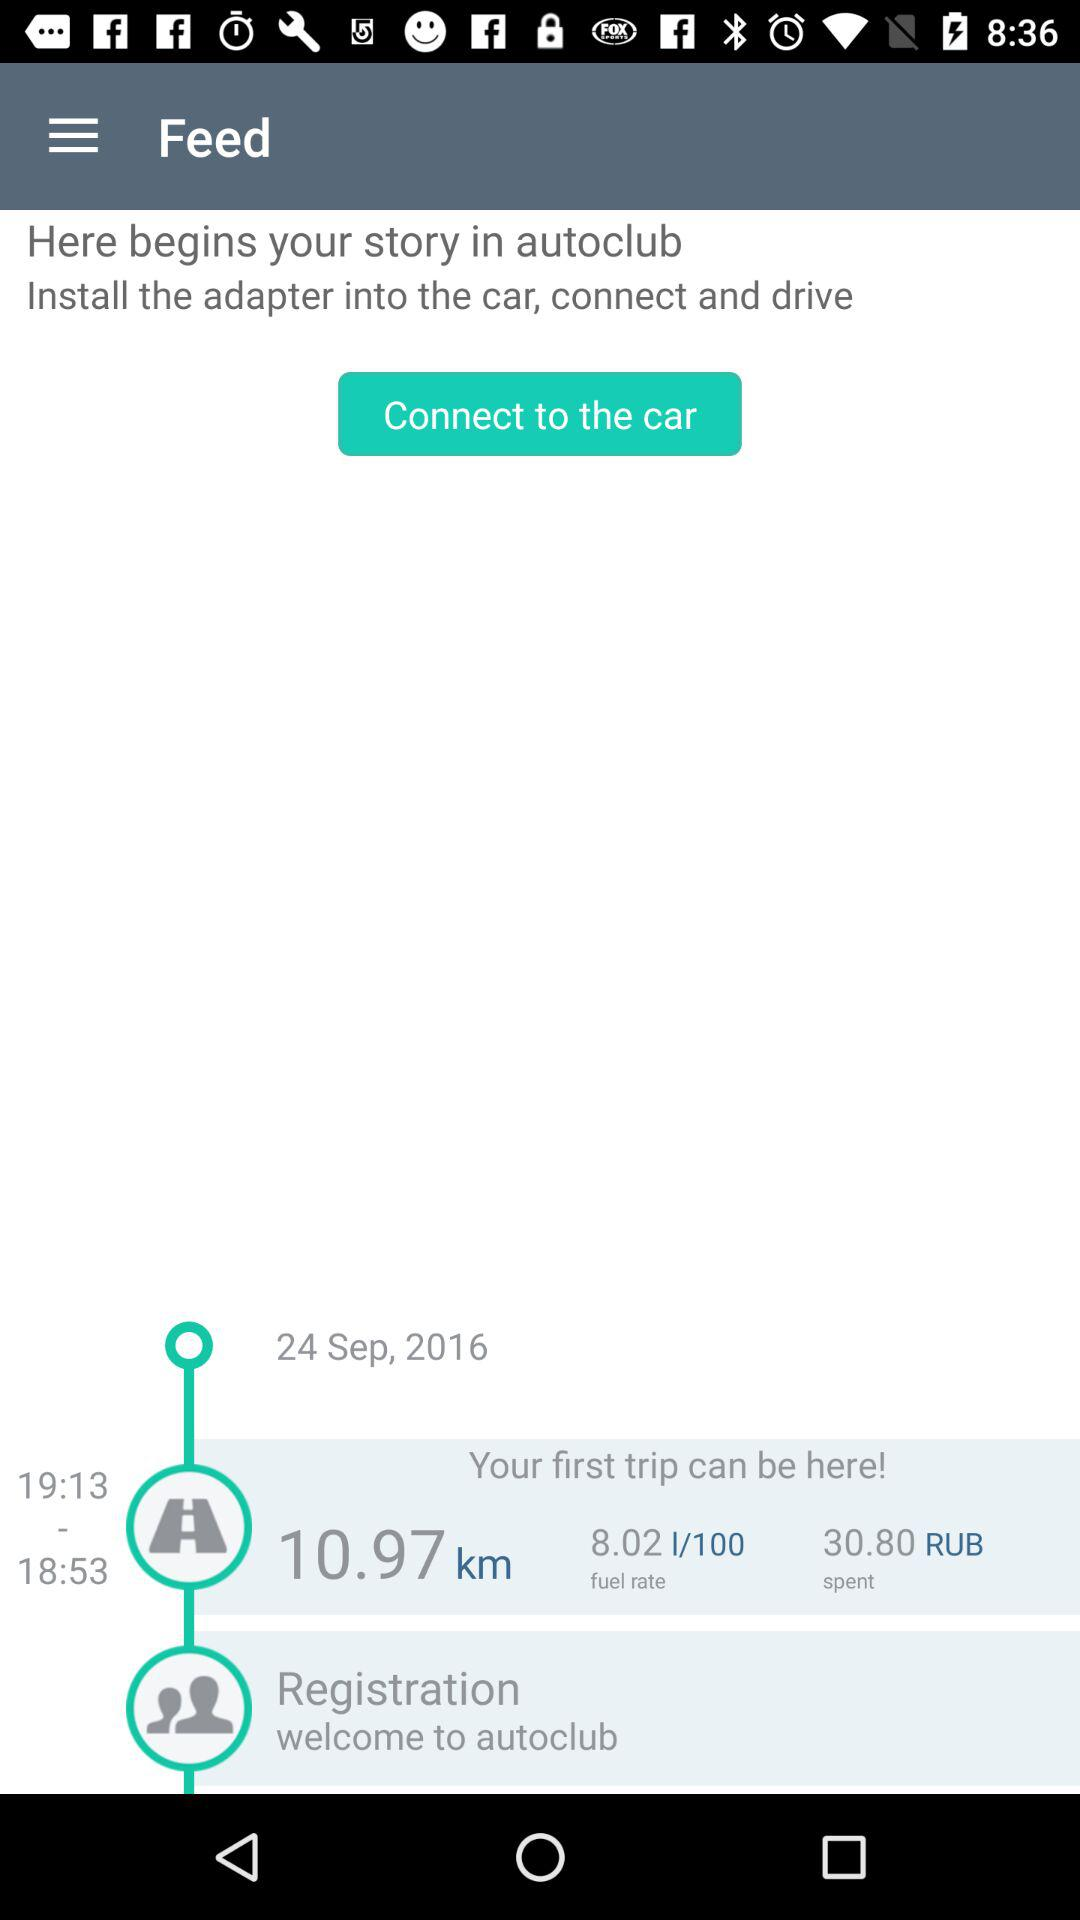What is the total distance travelled in this trip?
Answer the question using a single word or phrase. 10.97 km 